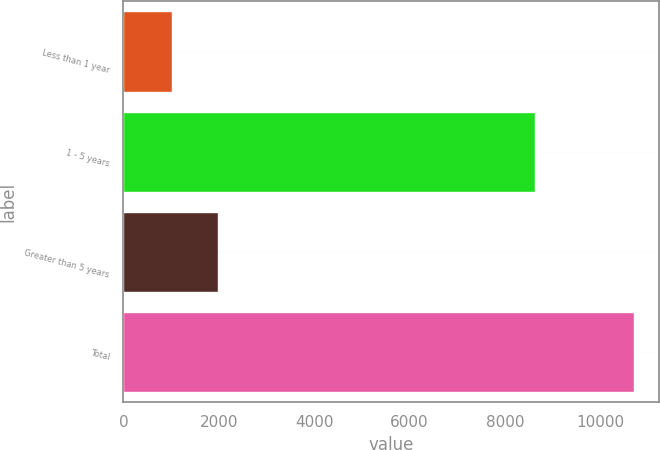<chart> <loc_0><loc_0><loc_500><loc_500><bar_chart><fcel>Less than 1 year<fcel>1 - 5 years<fcel>Greater than 5 years<fcel>Total<nl><fcel>1016<fcel>8643<fcel>1984.8<fcel>10704<nl></chart> 